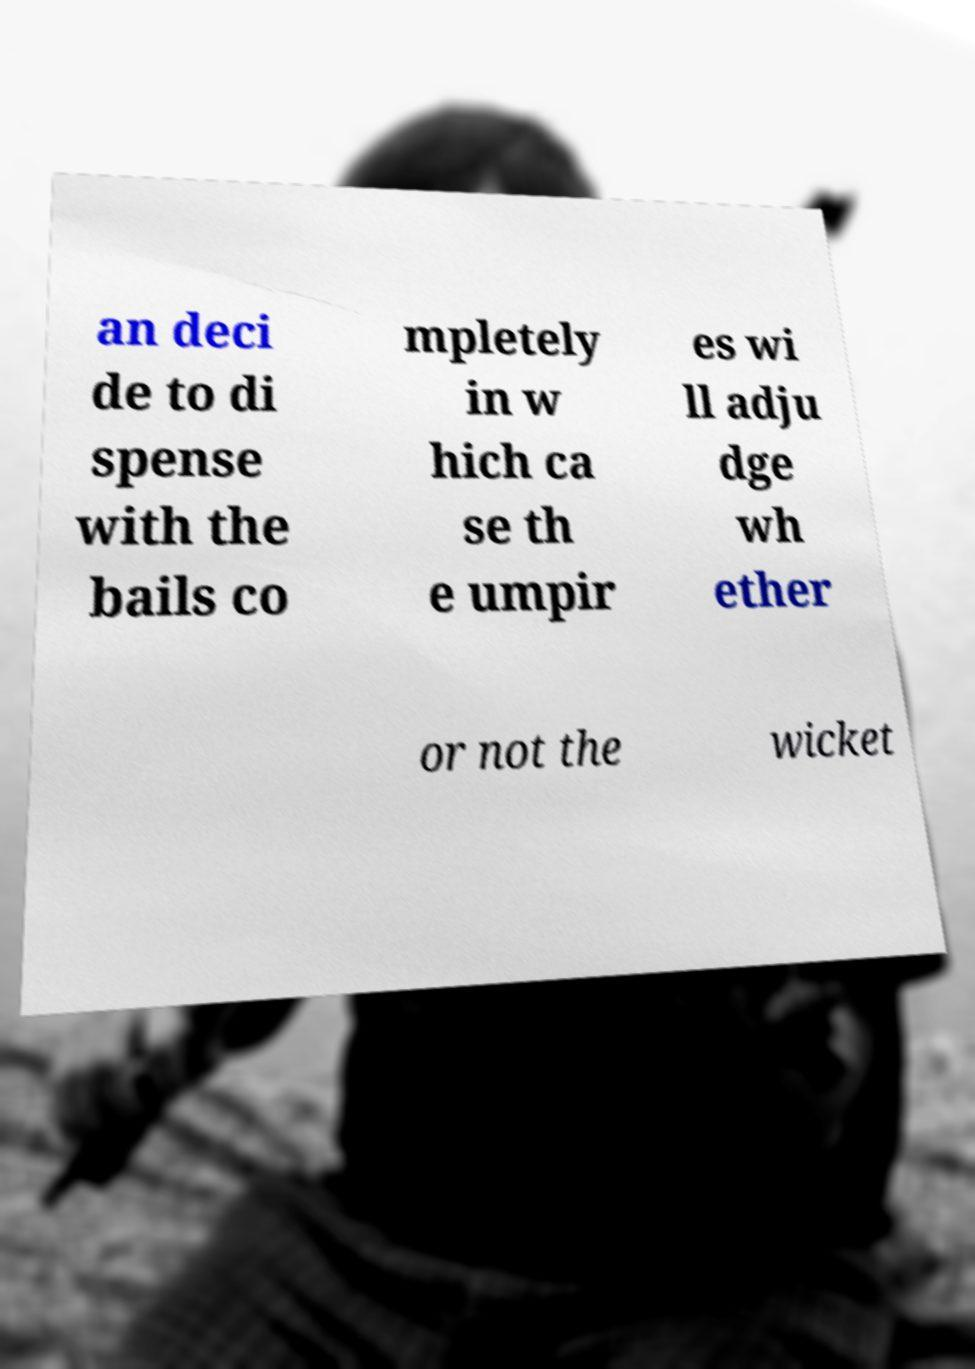Can you accurately transcribe the text from the provided image for me? an deci de to di spense with the bails co mpletely in w hich ca se th e umpir es wi ll adju dge wh ether or not the wicket 